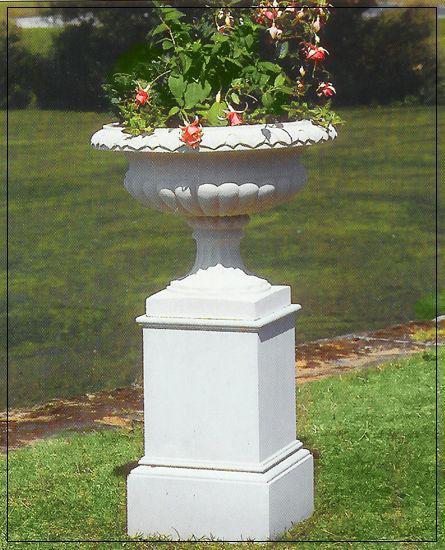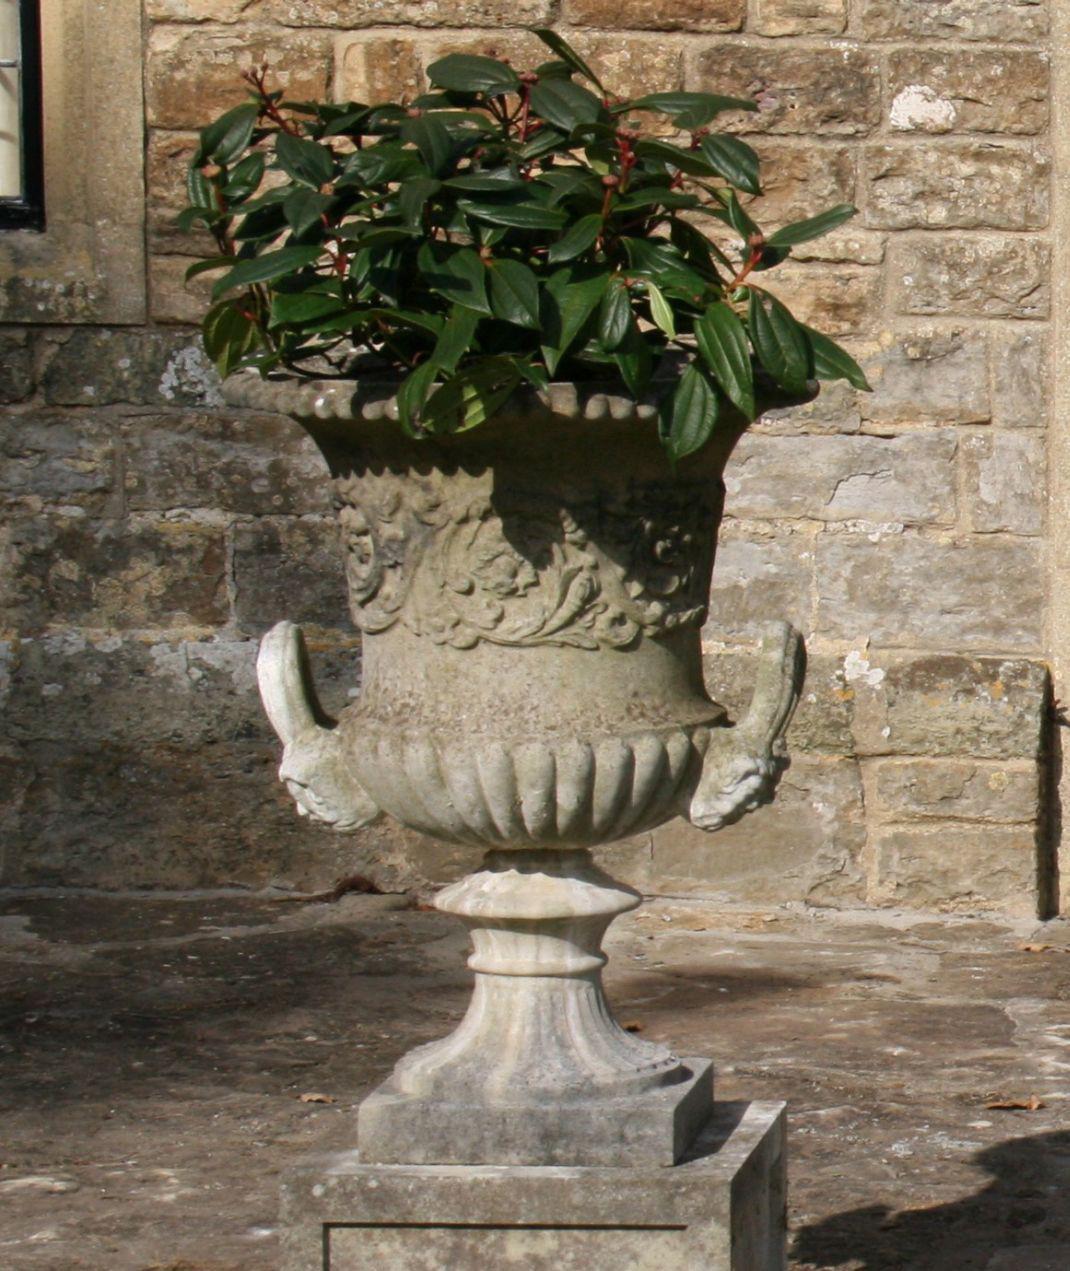The first image is the image on the left, the second image is the image on the right. Evaluate the accuracy of this statement regarding the images: "All planters are grey stone-look material and sit on square pedestal bases, and at least one planter holds a plant,". Is it true? Answer yes or no. Yes. The first image is the image on the left, the second image is the image on the right. For the images displayed, is the sentence "There are no more than three urns." factually correct? Answer yes or no. Yes. 